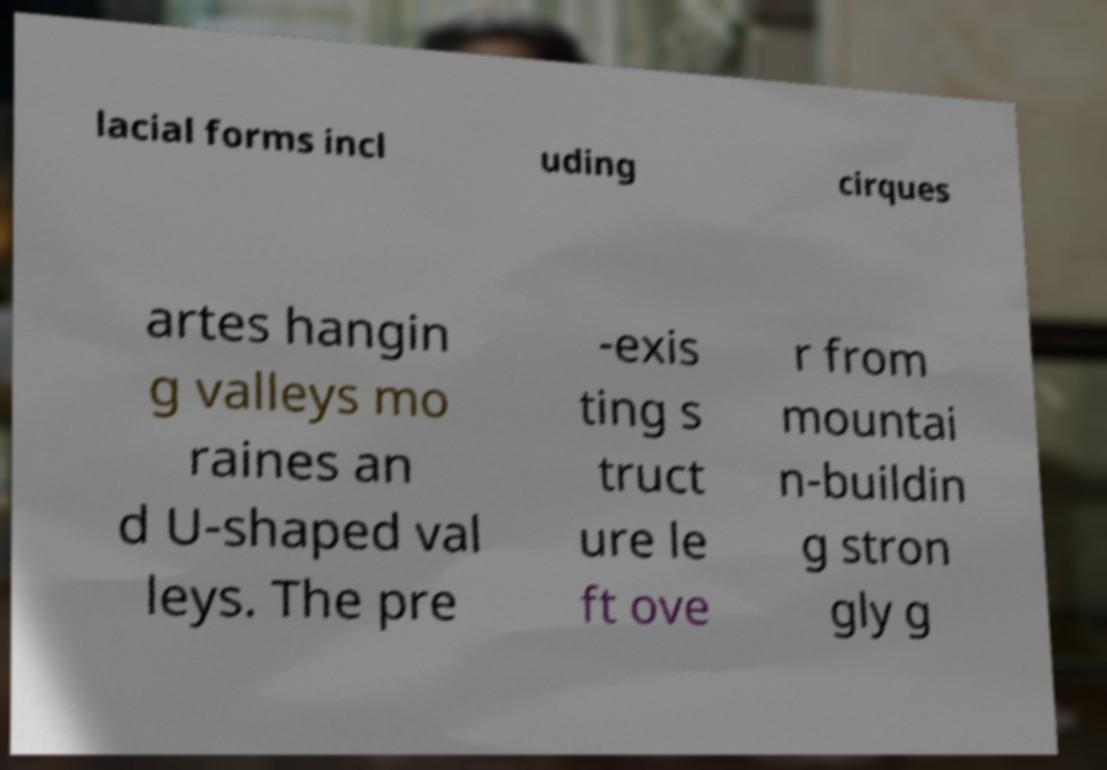Please identify and transcribe the text found in this image. lacial forms incl uding cirques artes hangin g valleys mo raines an d U-shaped val leys. The pre -exis ting s truct ure le ft ove r from mountai n-buildin g stron gly g 